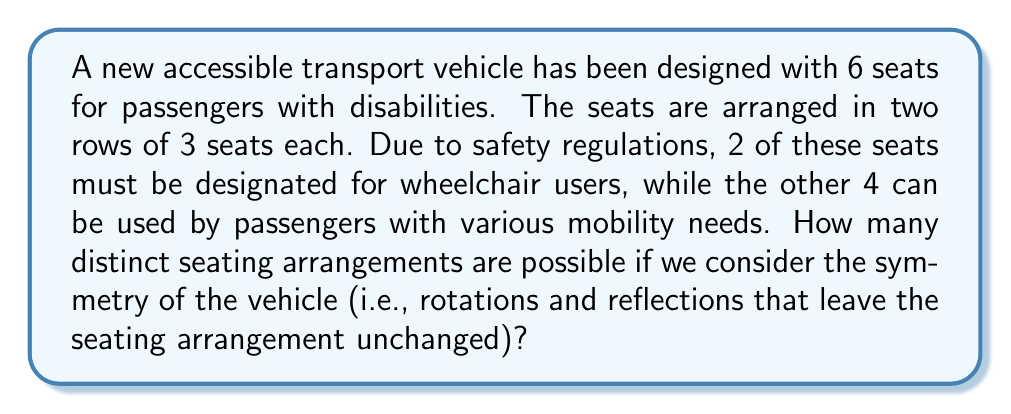Can you solve this math problem? Let's approach this problem using group theory:

1) First, we need to identify the symmetry group of the seating arrangement. The seats form a rectangular array with 2 rows and 3 columns. This arrangement has the symmetry group $D_2$, which includes:
   - The identity transformation
   - 180° rotation
   - Reflection across the horizontal axis
   - Reflection across the vertical axis

2) The total number of ways to arrange 2 wheelchair seats among 6 seats is $\binom{6}{2} = 15$.

3) However, some of these arrangements will be equivalent under the symmetry operations of $D_2$. We need to use Burnside's lemma to count the number of distinct arrangements under this group action.

4) Burnside's lemma states that the number of orbits $|X/G|$ is given by:

   $$|X/G| = \frac{1}{|G|} \sum_{g \in G} |X^g|$$

   where $|G|$ is the order of the group, and $|X^g|$ is the number of elements fixed by each group element $g$.

5) Let's count the fixed points for each symmetry operation:
   - Identity: All 15 arrangements are fixed
   - 180° rotation: Only arrangements with wheelchairs in opposite corners are fixed (1 arrangement)
   - Horizontal reflection: Arrangements with wheelchairs in the same row are fixed (3 arrangements)
   - Vertical reflection: Arrangements with wheelchairs in the middle column or in opposite outer columns are fixed (3 arrangements)

6) Applying Burnside's lemma:

   $$|X/G| = \frac{1}{4}(15 + 1 + 3 + 3) = \frac{22}{4} = 5.5$$

7) Since we're counting distinct arrangements, we round down to the nearest integer.
Answer: There are 5 distinct seating arrangements possible when considering the symmetry of the vehicle. 